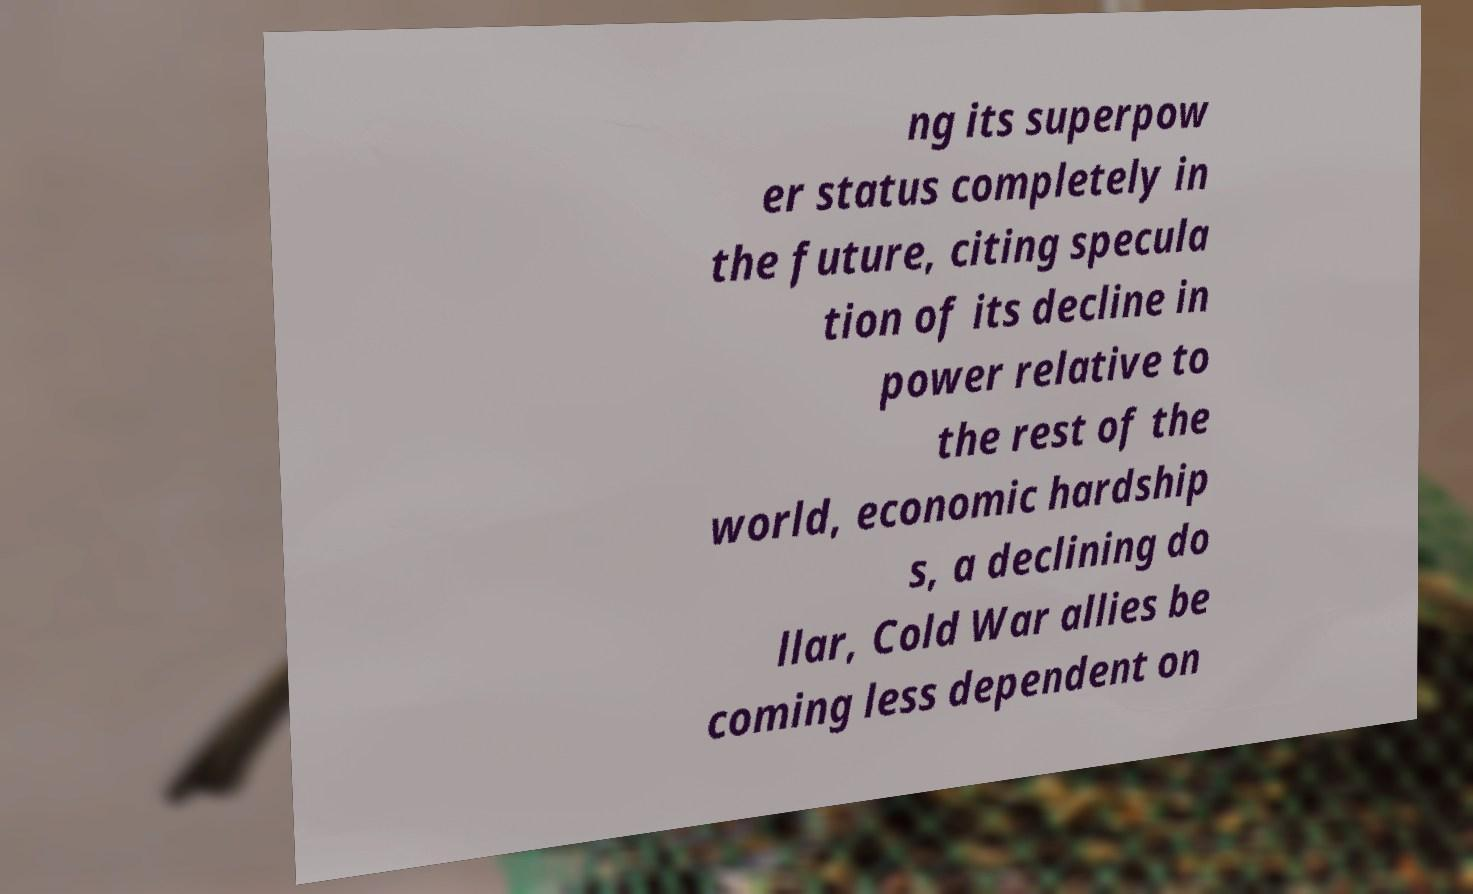What messages or text are displayed in this image? I need them in a readable, typed format. ng its superpow er status completely in the future, citing specula tion of its decline in power relative to the rest of the world, economic hardship s, a declining do llar, Cold War allies be coming less dependent on 